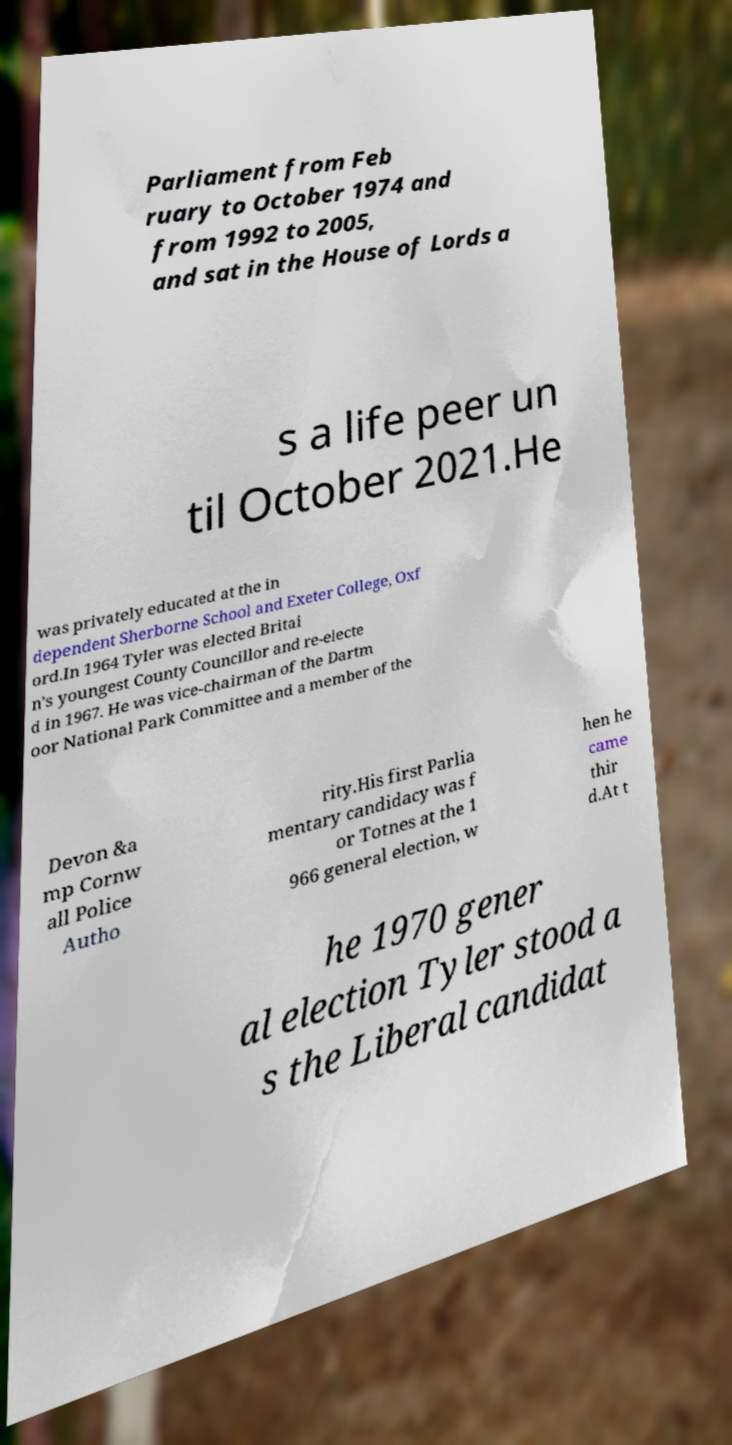Could you extract and type out the text from this image? Parliament from Feb ruary to October 1974 and from 1992 to 2005, and sat in the House of Lords a s a life peer un til October 2021.He was privately educated at the in dependent Sherborne School and Exeter College, Oxf ord.In 1964 Tyler was elected Britai n's youngest County Councillor and re-electe d in 1967. He was vice-chairman of the Dartm oor National Park Committee and a member of the Devon &a mp Cornw all Police Autho rity.His first Parlia mentary candidacy was f or Totnes at the 1 966 general election, w hen he came thir d.At t he 1970 gener al election Tyler stood a s the Liberal candidat 